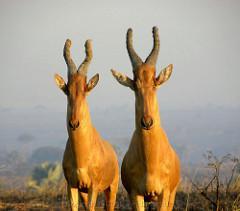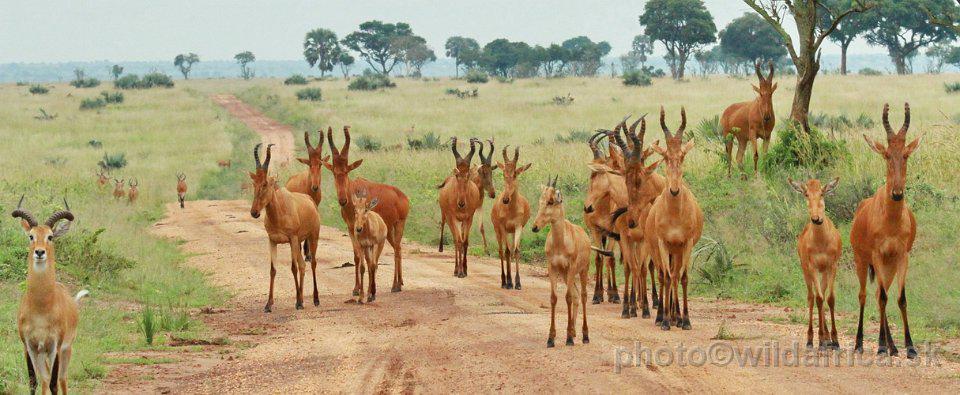The first image is the image on the left, the second image is the image on the right. Assess this claim about the two images: "At least 7 hartebeests walk down a dirt road.". Correct or not? Answer yes or no. Yes. The first image is the image on the left, the second image is the image on the right. Given the left and right images, does the statement "There are only two horned animals standing outside, one in each image." hold true? Answer yes or no. No. 